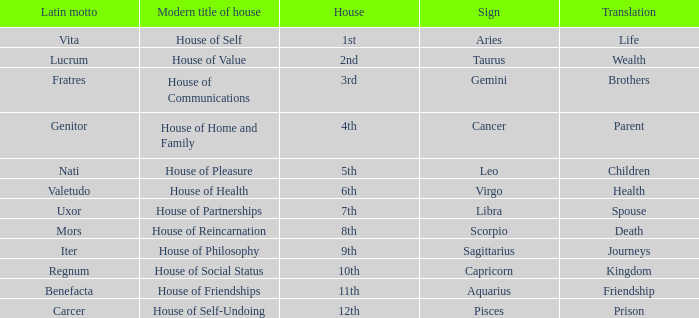Which sign has a modern house title of House of Partnerships? Libra. 